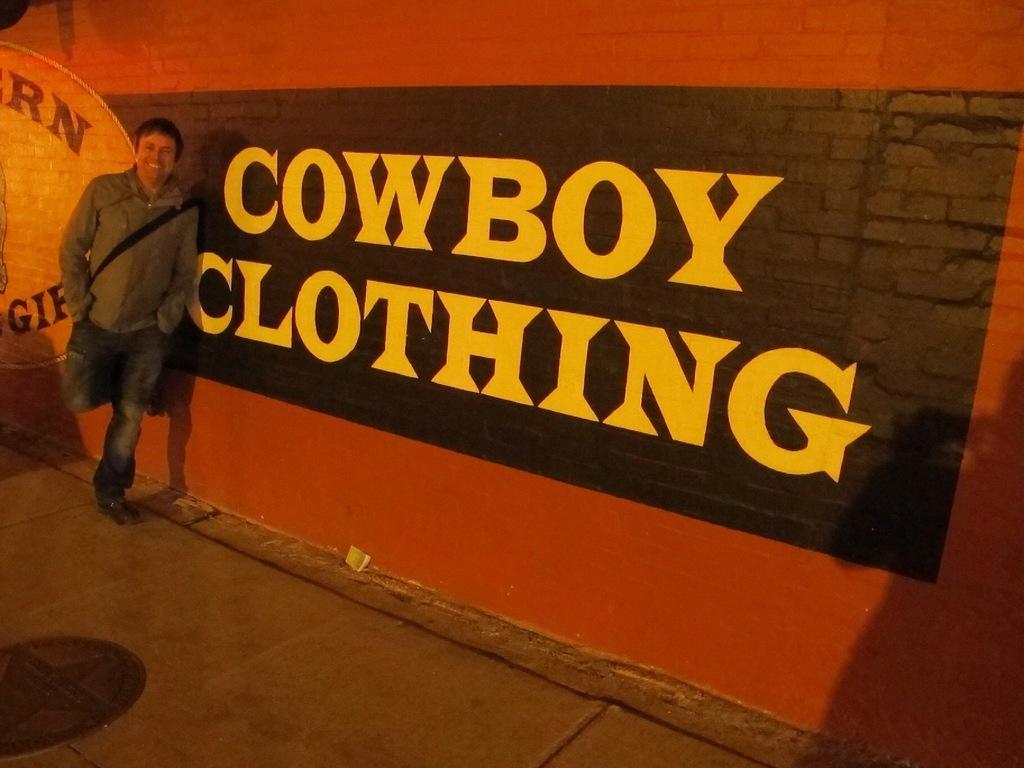Could you give a brief overview of what you see in this image? This image consists of a man wearing a gray jacket is standing. On the right, we can see a text and painting on the wall. At the bottom, there is a floor. He is also wearing a bag. 